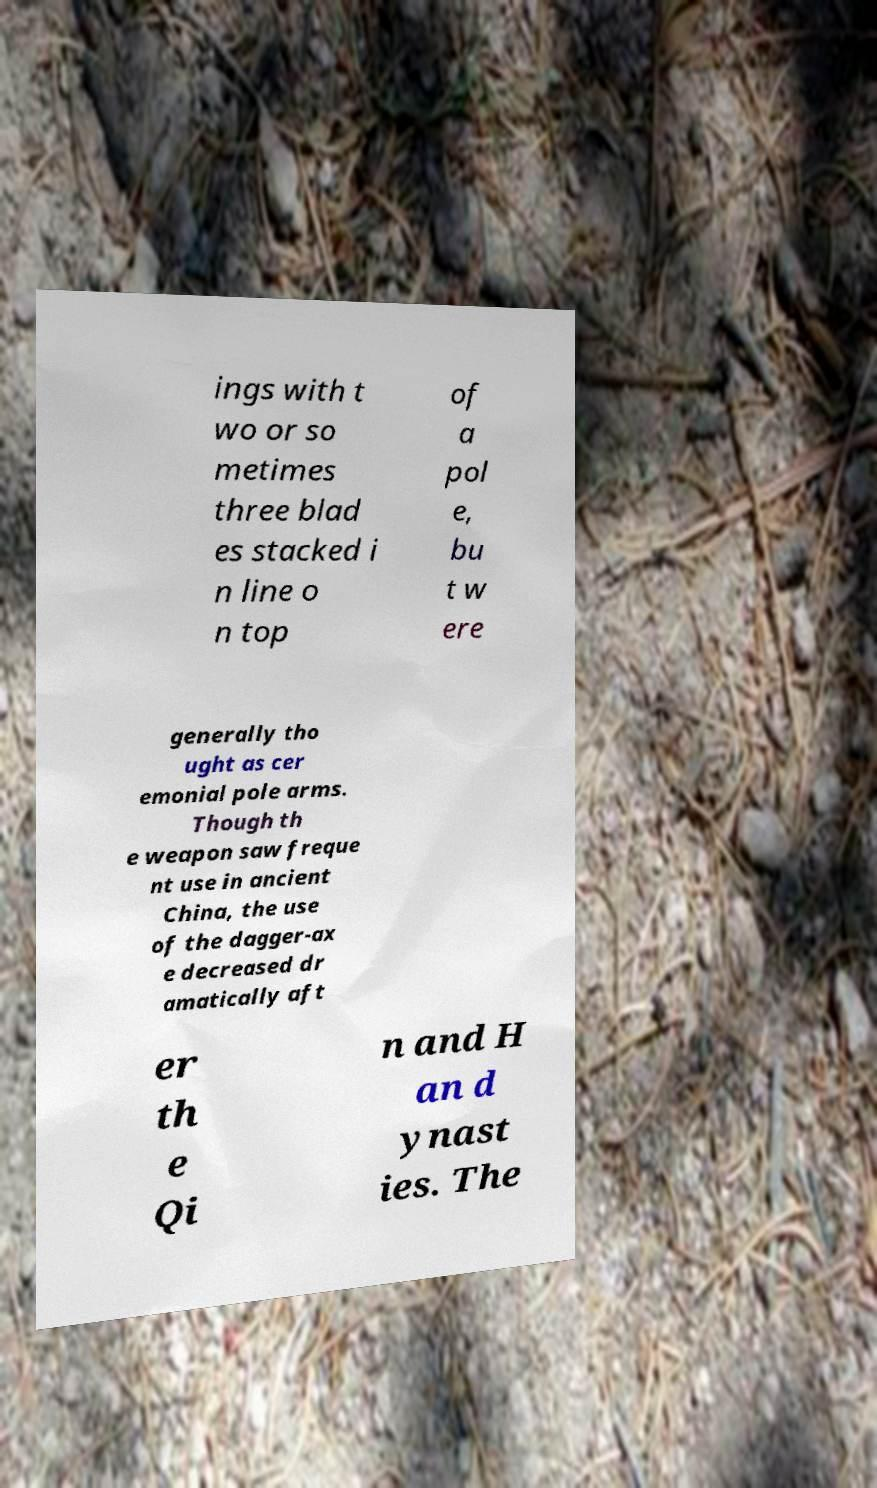For documentation purposes, I need the text within this image transcribed. Could you provide that? ings with t wo or so metimes three blad es stacked i n line o n top of a pol e, bu t w ere generally tho ught as cer emonial pole arms. Though th e weapon saw freque nt use in ancient China, the use of the dagger-ax e decreased dr amatically aft er th e Qi n and H an d ynast ies. The 